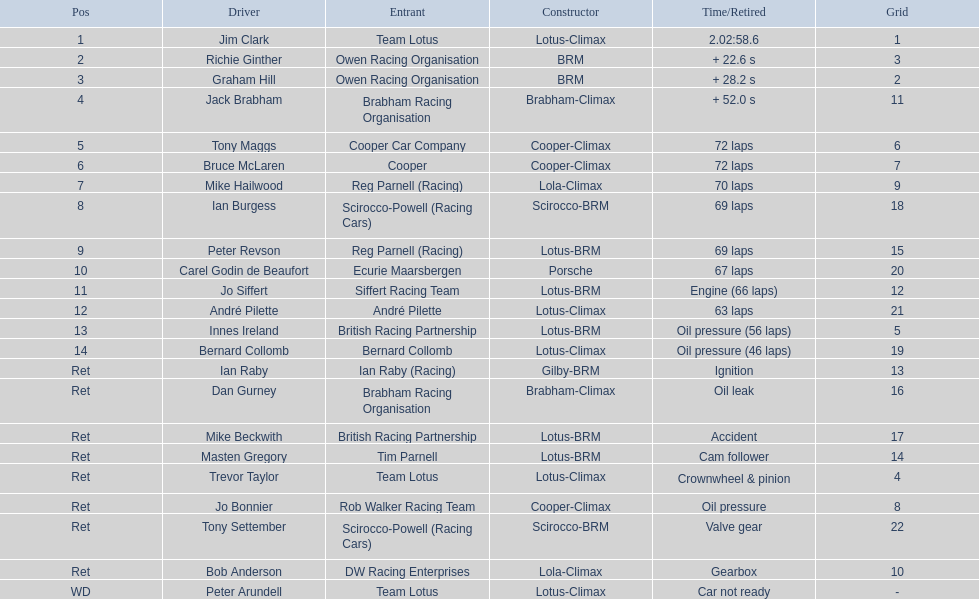Who came in earlier, tony maggs or jo siffert? Tony Maggs. 